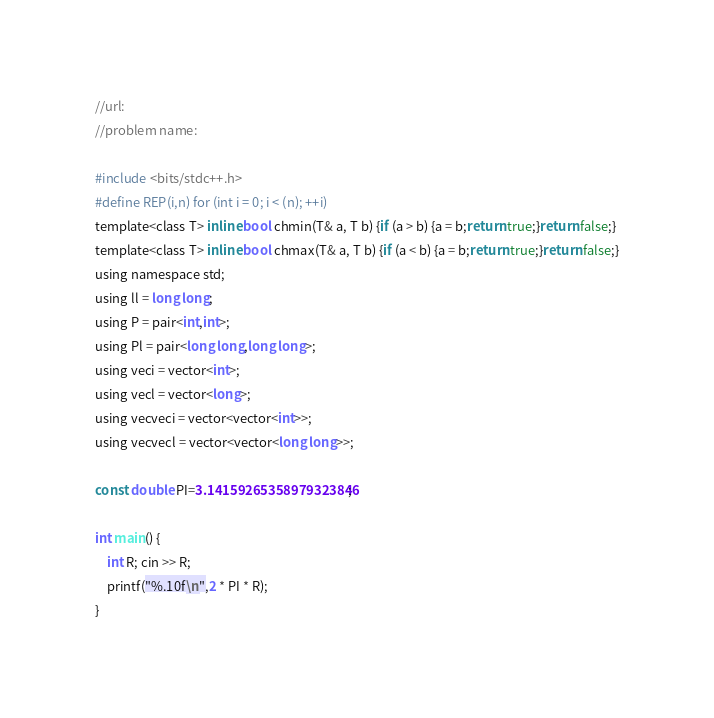<code> <loc_0><loc_0><loc_500><loc_500><_C_>//url:
//problem name:

#include <bits/stdc++.h>
#define REP(i,n) for (int i = 0; i < (n); ++i)
template<class T> inline bool chmin(T& a, T b) {if (a > b) {a = b;return true;}return false;}
template<class T> inline bool chmax(T& a, T b) {if (a < b) {a = b;return true;}return false;}
using namespace std;
using ll = long long;
using P = pair<int,int>;
using Pl = pair<long long,long long>;
using veci = vector<int>;
using vecl = vector<long>;
using vecveci = vector<vector<int>>;
using vecvecl = vector<vector<long long>>;

const double PI=3.14159265358979323846;

int main() {
    int R; cin >> R;
    printf("%.10f\n",2 * PI * R);
}</code> 